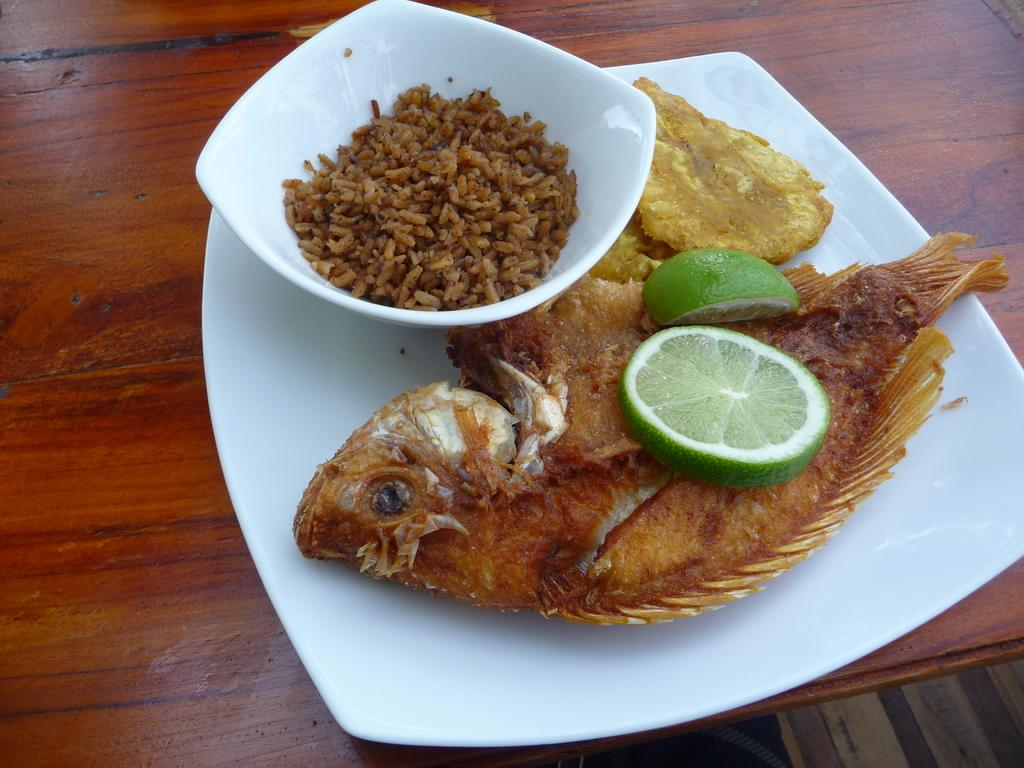What is on the table in the image? There is a plate and a bowl on the table in the image. What is on the plate? The plate contains a fried fish and lemon pieces. What is in the bowl? The bowl contains fried rice. What type of sofa can be seen in the scene? There is no sofa present in the image; it only shows a plate with fried fish and lemon pieces, and a bowl with fried rice on a table. 